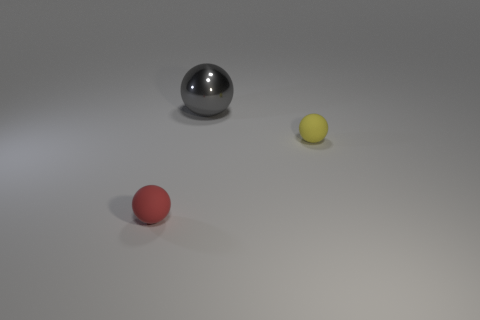Are there any other things that are the same shape as the tiny yellow rubber thing?
Offer a terse response. Yes. What is the sphere on the right side of the large gray sphere made of?
Your answer should be very brief. Rubber. Does the small sphere on the left side of the gray ball have the same material as the gray ball?
Make the answer very short. No. What number of objects are tiny green cylinders or large gray objects that are to the right of the tiny red rubber object?
Make the answer very short. 1. What is the size of the yellow object that is the same shape as the gray thing?
Make the answer very short. Small. Is there anything else that is the same size as the red ball?
Provide a short and direct response. Yes. There is a tiny yellow sphere; are there any yellow matte objects behind it?
Ensure brevity in your answer.  No. There is a matte thing right of the small red sphere; does it have the same color as the tiny matte thing that is left of the large gray shiny ball?
Provide a succinct answer. No. Is there a small blue matte thing of the same shape as the metal thing?
Make the answer very short. No. How many other objects are the same color as the big sphere?
Keep it short and to the point. 0. 